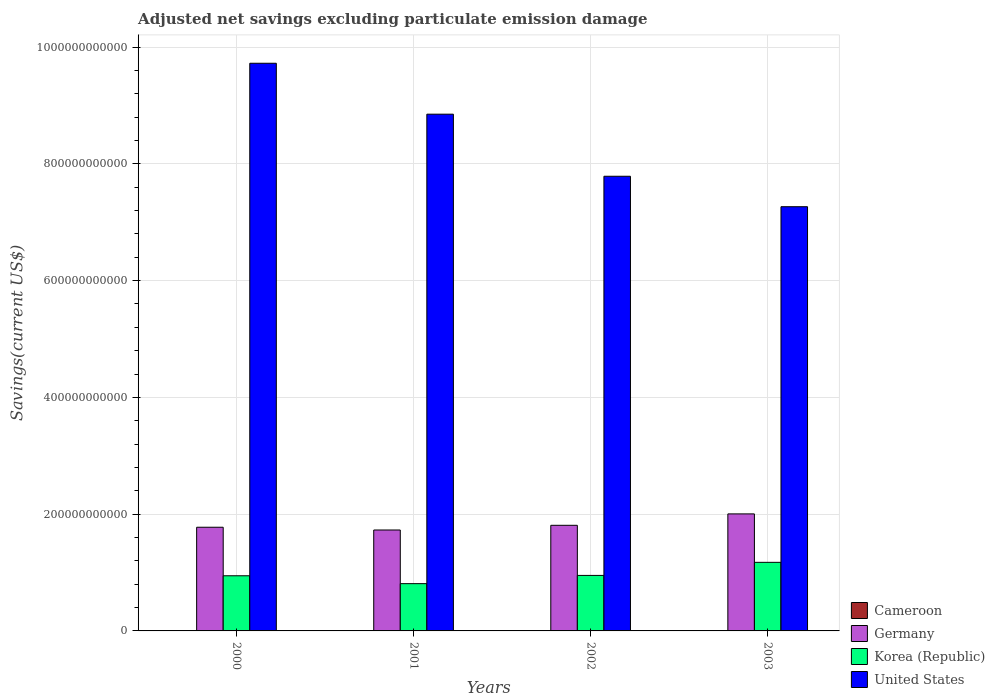Are the number of bars per tick equal to the number of legend labels?
Provide a short and direct response. No. Are the number of bars on each tick of the X-axis equal?
Offer a terse response. No. In how many cases, is the number of bars for a given year not equal to the number of legend labels?
Keep it short and to the point. 3. What is the adjusted net savings in Korea (Republic) in 2002?
Provide a short and direct response. 9.51e+1. Across all years, what is the maximum adjusted net savings in Korea (Republic)?
Make the answer very short. 1.17e+11. Across all years, what is the minimum adjusted net savings in Cameroon?
Offer a very short reply. 0. What is the total adjusted net savings in Germany in the graph?
Provide a succinct answer. 7.32e+11. What is the difference between the adjusted net savings in Germany in 2000 and that in 2003?
Your response must be concise. -2.28e+1. What is the difference between the adjusted net savings in Cameroon in 2003 and the adjusted net savings in Korea (Republic) in 2001?
Your answer should be compact. -8.09e+1. What is the average adjusted net savings in United States per year?
Offer a terse response. 8.41e+11. In the year 2000, what is the difference between the adjusted net savings in Germany and adjusted net savings in United States?
Keep it short and to the point. -7.95e+11. In how many years, is the adjusted net savings in United States greater than 480000000000 US$?
Your response must be concise. 4. What is the ratio of the adjusted net savings in Germany in 2002 to that in 2003?
Keep it short and to the point. 0.9. Is the adjusted net savings in Germany in 2001 less than that in 2002?
Offer a terse response. Yes. Is the difference between the adjusted net savings in Germany in 2001 and 2002 greater than the difference between the adjusted net savings in United States in 2001 and 2002?
Provide a succinct answer. No. What is the difference between the highest and the second highest adjusted net savings in United States?
Offer a very short reply. 8.72e+1. What is the difference between the highest and the lowest adjusted net savings in United States?
Your response must be concise. 2.46e+11. Is the sum of the adjusted net savings in Germany in 2000 and 2001 greater than the maximum adjusted net savings in United States across all years?
Provide a succinct answer. No. Is it the case that in every year, the sum of the adjusted net savings in Germany and adjusted net savings in Cameroon is greater than the sum of adjusted net savings in United States and adjusted net savings in Korea (Republic)?
Ensure brevity in your answer.  No. How many bars are there?
Your answer should be very brief. 13. How many years are there in the graph?
Offer a terse response. 4. What is the difference between two consecutive major ticks on the Y-axis?
Your answer should be very brief. 2.00e+11. Are the values on the major ticks of Y-axis written in scientific E-notation?
Provide a short and direct response. No. Does the graph contain grids?
Give a very brief answer. Yes. Where does the legend appear in the graph?
Offer a terse response. Bottom right. How many legend labels are there?
Ensure brevity in your answer.  4. What is the title of the graph?
Provide a short and direct response. Adjusted net savings excluding particulate emission damage. Does "Cayman Islands" appear as one of the legend labels in the graph?
Ensure brevity in your answer.  No. What is the label or title of the Y-axis?
Your answer should be compact. Savings(current US$). What is the Savings(current US$) in Cameroon in 2000?
Your answer should be very brief. 0. What is the Savings(current US$) in Germany in 2000?
Offer a terse response. 1.78e+11. What is the Savings(current US$) of Korea (Republic) in 2000?
Your response must be concise. 9.45e+1. What is the Savings(current US$) of United States in 2000?
Provide a succinct answer. 9.72e+11. What is the Savings(current US$) in Cameroon in 2001?
Keep it short and to the point. 0. What is the Savings(current US$) in Germany in 2001?
Make the answer very short. 1.73e+11. What is the Savings(current US$) of Korea (Republic) in 2001?
Keep it short and to the point. 8.10e+1. What is the Savings(current US$) in United States in 2001?
Offer a very short reply. 8.85e+11. What is the Savings(current US$) in Cameroon in 2002?
Provide a succinct answer. 0. What is the Savings(current US$) of Germany in 2002?
Offer a terse response. 1.81e+11. What is the Savings(current US$) of Korea (Republic) in 2002?
Provide a succinct answer. 9.51e+1. What is the Savings(current US$) of United States in 2002?
Offer a terse response. 7.79e+11. What is the Savings(current US$) of Cameroon in 2003?
Make the answer very short. 9.25e+07. What is the Savings(current US$) of Germany in 2003?
Make the answer very short. 2.00e+11. What is the Savings(current US$) in Korea (Republic) in 2003?
Ensure brevity in your answer.  1.17e+11. What is the Savings(current US$) in United States in 2003?
Your answer should be very brief. 7.27e+11. Across all years, what is the maximum Savings(current US$) of Cameroon?
Your response must be concise. 9.25e+07. Across all years, what is the maximum Savings(current US$) of Germany?
Provide a short and direct response. 2.00e+11. Across all years, what is the maximum Savings(current US$) in Korea (Republic)?
Make the answer very short. 1.17e+11. Across all years, what is the maximum Savings(current US$) of United States?
Your answer should be very brief. 9.72e+11. Across all years, what is the minimum Savings(current US$) in Germany?
Provide a succinct answer. 1.73e+11. Across all years, what is the minimum Savings(current US$) in Korea (Republic)?
Your answer should be very brief. 8.10e+1. Across all years, what is the minimum Savings(current US$) of United States?
Provide a short and direct response. 7.27e+11. What is the total Savings(current US$) in Cameroon in the graph?
Your response must be concise. 9.25e+07. What is the total Savings(current US$) in Germany in the graph?
Make the answer very short. 7.32e+11. What is the total Savings(current US$) of Korea (Republic) in the graph?
Provide a succinct answer. 3.88e+11. What is the total Savings(current US$) of United States in the graph?
Your response must be concise. 3.36e+12. What is the difference between the Savings(current US$) in Germany in 2000 and that in 2001?
Provide a short and direct response. 4.73e+09. What is the difference between the Savings(current US$) of Korea (Republic) in 2000 and that in 2001?
Provide a short and direct response. 1.35e+1. What is the difference between the Savings(current US$) of United States in 2000 and that in 2001?
Give a very brief answer. 8.72e+1. What is the difference between the Savings(current US$) of Germany in 2000 and that in 2002?
Your answer should be compact. -3.30e+09. What is the difference between the Savings(current US$) in Korea (Republic) in 2000 and that in 2002?
Your response must be concise. -6.15e+08. What is the difference between the Savings(current US$) in United States in 2000 and that in 2002?
Ensure brevity in your answer.  1.94e+11. What is the difference between the Savings(current US$) in Germany in 2000 and that in 2003?
Offer a very short reply. -2.28e+1. What is the difference between the Savings(current US$) in Korea (Republic) in 2000 and that in 2003?
Give a very brief answer. -2.30e+1. What is the difference between the Savings(current US$) in United States in 2000 and that in 2003?
Provide a short and direct response. 2.46e+11. What is the difference between the Savings(current US$) of Germany in 2001 and that in 2002?
Ensure brevity in your answer.  -8.03e+09. What is the difference between the Savings(current US$) in Korea (Republic) in 2001 and that in 2002?
Provide a short and direct response. -1.41e+1. What is the difference between the Savings(current US$) in United States in 2001 and that in 2002?
Give a very brief answer. 1.06e+11. What is the difference between the Savings(current US$) of Germany in 2001 and that in 2003?
Your answer should be compact. -2.76e+1. What is the difference between the Savings(current US$) of Korea (Republic) in 2001 and that in 2003?
Provide a short and direct response. -3.65e+1. What is the difference between the Savings(current US$) of United States in 2001 and that in 2003?
Offer a terse response. 1.58e+11. What is the difference between the Savings(current US$) in Germany in 2002 and that in 2003?
Ensure brevity in your answer.  -1.95e+1. What is the difference between the Savings(current US$) of Korea (Republic) in 2002 and that in 2003?
Your answer should be compact. -2.24e+1. What is the difference between the Savings(current US$) of United States in 2002 and that in 2003?
Keep it short and to the point. 5.22e+1. What is the difference between the Savings(current US$) in Germany in 2000 and the Savings(current US$) in Korea (Republic) in 2001?
Your response must be concise. 9.66e+1. What is the difference between the Savings(current US$) of Germany in 2000 and the Savings(current US$) of United States in 2001?
Give a very brief answer. -7.08e+11. What is the difference between the Savings(current US$) in Korea (Republic) in 2000 and the Savings(current US$) in United States in 2001?
Offer a very short reply. -7.91e+11. What is the difference between the Savings(current US$) of Germany in 2000 and the Savings(current US$) of Korea (Republic) in 2002?
Make the answer very short. 8.25e+1. What is the difference between the Savings(current US$) of Germany in 2000 and the Savings(current US$) of United States in 2002?
Provide a succinct answer. -6.01e+11. What is the difference between the Savings(current US$) of Korea (Republic) in 2000 and the Savings(current US$) of United States in 2002?
Offer a terse response. -6.84e+11. What is the difference between the Savings(current US$) of Germany in 2000 and the Savings(current US$) of Korea (Republic) in 2003?
Keep it short and to the point. 6.01e+1. What is the difference between the Savings(current US$) of Germany in 2000 and the Savings(current US$) of United States in 2003?
Your answer should be compact. -5.49e+11. What is the difference between the Savings(current US$) in Korea (Republic) in 2000 and the Savings(current US$) in United States in 2003?
Offer a terse response. -6.32e+11. What is the difference between the Savings(current US$) in Germany in 2001 and the Savings(current US$) in Korea (Republic) in 2002?
Provide a succinct answer. 7.78e+1. What is the difference between the Savings(current US$) in Germany in 2001 and the Savings(current US$) in United States in 2002?
Your response must be concise. -6.06e+11. What is the difference between the Savings(current US$) of Korea (Republic) in 2001 and the Savings(current US$) of United States in 2002?
Your answer should be very brief. -6.98e+11. What is the difference between the Savings(current US$) of Germany in 2001 and the Savings(current US$) of Korea (Republic) in 2003?
Offer a very short reply. 5.54e+1. What is the difference between the Savings(current US$) of Germany in 2001 and the Savings(current US$) of United States in 2003?
Make the answer very short. -5.54e+11. What is the difference between the Savings(current US$) in Korea (Republic) in 2001 and the Savings(current US$) in United States in 2003?
Keep it short and to the point. -6.46e+11. What is the difference between the Savings(current US$) in Germany in 2002 and the Savings(current US$) in Korea (Republic) in 2003?
Give a very brief answer. 6.34e+1. What is the difference between the Savings(current US$) of Germany in 2002 and the Savings(current US$) of United States in 2003?
Offer a very short reply. -5.46e+11. What is the difference between the Savings(current US$) in Korea (Republic) in 2002 and the Savings(current US$) in United States in 2003?
Your response must be concise. -6.32e+11. What is the average Savings(current US$) of Cameroon per year?
Offer a terse response. 2.31e+07. What is the average Savings(current US$) of Germany per year?
Keep it short and to the point. 1.83e+11. What is the average Savings(current US$) of Korea (Republic) per year?
Ensure brevity in your answer.  9.70e+1. What is the average Savings(current US$) of United States per year?
Your response must be concise. 8.41e+11. In the year 2000, what is the difference between the Savings(current US$) of Germany and Savings(current US$) of Korea (Republic)?
Provide a short and direct response. 8.31e+1. In the year 2000, what is the difference between the Savings(current US$) of Germany and Savings(current US$) of United States?
Your answer should be very brief. -7.95e+11. In the year 2000, what is the difference between the Savings(current US$) in Korea (Republic) and Savings(current US$) in United States?
Your response must be concise. -8.78e+11. In the year 2001, what is the difference between the Savings(current US$) of Germany and Savings(current US$) of Korea (Republic)?
Your answer should be very brief. 9.19e+1. In the year 2001, what is the difference between the Savings(current US$) in Germany and Savings(current US$) in United States?
Provide a succinct answer. -7.12e+11. In the year 2001, what is the difference between the Savings(current US$) of Korea (Republic) and Savings(current US$) of United States?
Your answer should be compact. -8.04e+11. In the year 2002, what is the difference between the Savings(current US$) of Germany and Savings(current US$) of Korea (Republic)?
Ensure brevity in your answer.  8.58e+1. In the year 2002, what is the difference between the Savings(current US$) of Germany and Savings(current US$) of United States?
Provide a succinct answer. -5.98e+11. In the year 2002, what is the difference between the Savings(current US$) in Korea (Republic) and Savings(current US$) in United States?
Provide a short and direct response. -6.84e+11. In the year 2003, what is the difference between the Savings(current US$) of Cameroon and Savings(current US$) of Germany?
Offer a very short reply. -2.00e+11. In the year 2003, what is the difference between the Savings(current US$) in Cameroon and Savings(current US$) in Korea (Republic)?
Provide a short and direct response. -1.17e+11. In the year 2003, what is the difference between the Savings(current US$) in Cameroon and Savings(current US$) in United States?
Ensure brevity in your answer.  -7.27e+11. In the year 2003, what is the difference between the Savings(current US$) in Germany and Savings(current US$) in Korea (Republic)?
Give a very brief answer. 8.30e+1. In the year 2003, what is the difference between the Savings(current US$) of Germany and Savings(current US$) of United States?
Ensure brevity in your answer.  -5.26e+11. In the year 2003, what is the difference between the Savings(current US$) of Korea (Republic) and Savings(current US$) of United States?
Provide a succinct answer. -6.09e+11. What is the ratio of the Savings(current US$) in Germany in 2000 to that in 2001?
Your response must be concise. 1.03. What is the ratio of the Savings(current US$) of Korea (Republic) in 2000 to that in 2001?
Keep it short and to the point. 1.17. What is the ratio of the Savings(current US$) in United States in 2000 to that in 2001?
Offer a terse response. 1.1. What is the ratio of the Savings(current US$) of Germany in 2000 to that in 2002?
Keep it short and to the point. 0.98. What is the ratio of the Savings(current US$) of United States in 2000 to that in 2002?
Provide a succinct answer. 1.25. What is the ratio of the Savings(current US$) of Germany in 2000 to that in 2003?
Give a very brief answer. 0.89. What is the ratio of the Savings(current US$) in Korea (Republic) in 2000 to that in 2003?
Provide a short and direct response. 0.8. What is the ratio of the Savings(current US$) in United States in 2000 to that in 2003?
Make the answer very short. 1.34. What is the ratio of the Savings(current US$) in Germany in 2001 to that in 2002?
Your response must be concise. 0.96. What is the ratio of the Savings(current US$) in Korea (Republic) in 2001 to that in 2002?
Your answer should be compact. 0.85. What is the ratio of the Savings(current US$) in United States in 2001 to that in 2002?
Provide a succinct answer. 1.14. What is the ratio of the Savings(current US$) in Germany in 2001 to that in 2003?
Offer a very short reply. 0.86. What is the ratio of the Savings(current US$) in Korea (Republic) in 2001 to that in 2003?
Ensure brevity in your answer.  0.69. What is the ratio of the Savings(current US$) of United States in 2001 to that in 2003?
Make the answer very short. 1.22. What is the ratio of the Savings(current US$) of Germany in 2002 to that in 2003?
Keep it short and to the point. 0.9. What is the ratio of the Savings(current US$) in Korea (Republic) in 2002 to that in 2003?
Your response must be concise. 0.81. What is the ratio of the Savings(current US$) of United States in 2002 to that in 2003?
Provide a short and direct response. 1.07. What is the difference between the highest and the second highest Savings(current US$) in Germany?
Give a very brief answer. 1.95e+1. What is the difference between the highest and the second highest Savings(current US$) in Korea (Republic)?
Make the answer very short. 2.24e+1. What is the difference between the highest and the second highest Savings(current US$) of United States?
Give a very brief answer. 8.72e+1. What is the difference between the highest and the lowest Savings(current US$) of Cameroon?
Offer a terse response. 9.25e+07. What is the difference between the highest and the lowest Savings(current US$) in Germany?
Provide a short and direct response. 2.76e+1. What is the difference between the highest and the lowest Savings(current US$) of Korea (Republic)?
Provide a short and direct response. 3.65e+1. What is the difference between the highest and the lowest Savings(current US$) in United States?
Offer a terse response. 2.46e+11. 